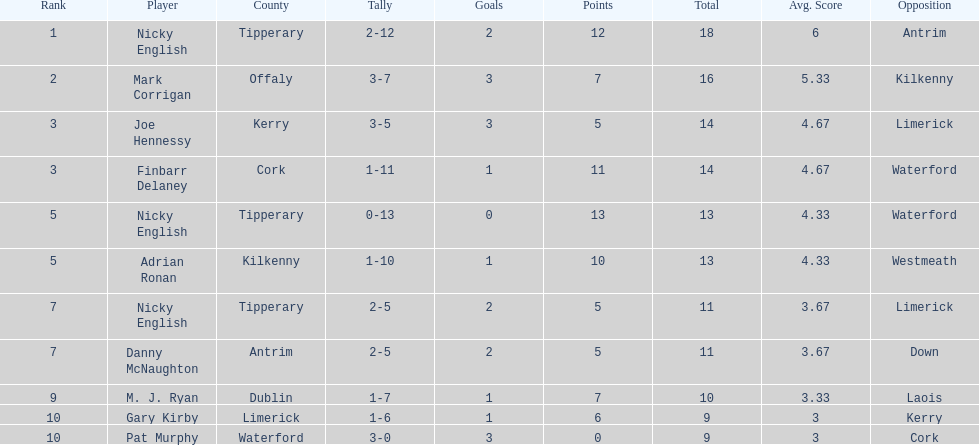Joe hennessy and finbarr delaney both scored how many points? 14. 